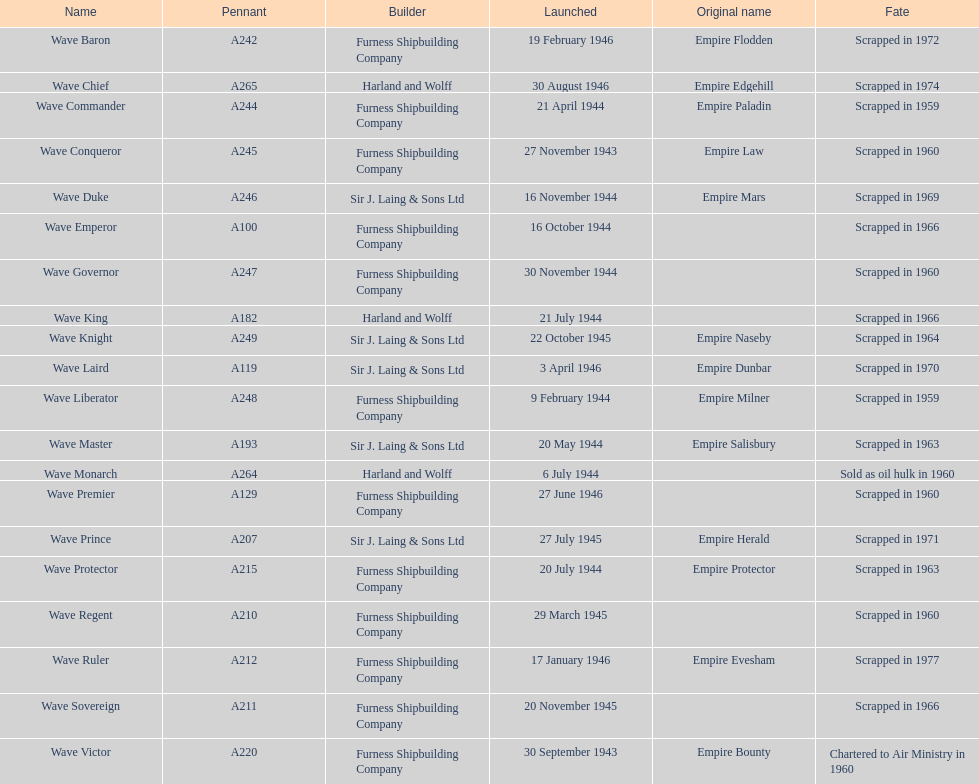What is the appellation of the ultimate ship that was taken apart? Wave Ruler. 